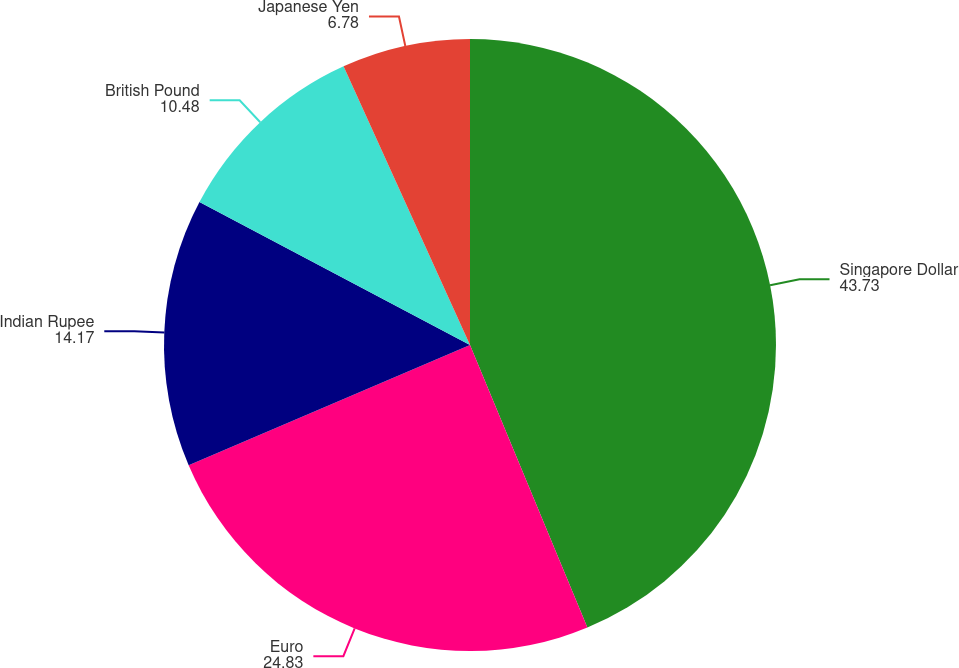Convert chart to OTSL. <chart><loc_0><loc_0><loc_500><loc_500><pie_chart><fcel>Singapore Dollar<fcel>Euro<fcel>Indian Rupee<fcel>British Pound<fcel>Japanese Yen<nl><fcel>43.73%<fcel>24.83%<fcel>14.17%<fcel>10.48%<fcel>6.78%<nl></chart> 